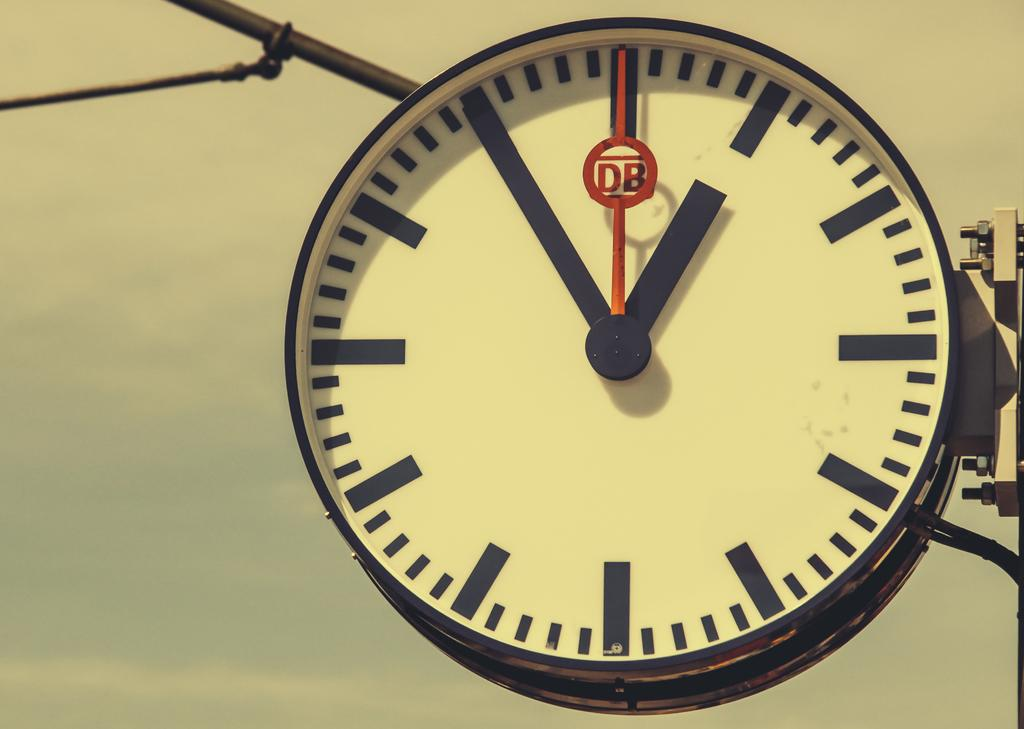What object in the image is used for measuring time? There is a clock in the image that is used for measuring time. What is the stand in the image used for? The stand in the image is likely used for supporting or displaying the clock. What can be seen in the background of the image? The sky is visible in the background of the image. Can you tell me how many geese are flying in the sky in the image? There are no geese visible in the sky in the image. What type of holiday is being celebrated in the image? There is no indication of a holiday being celebrated in the image. 